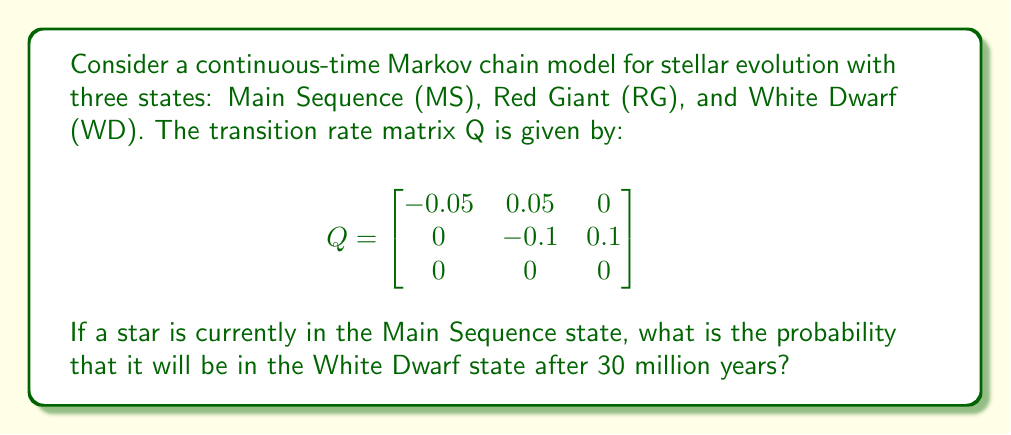What is the answer to this math problem? To solve this problem, we need to calculate the transition probability matrix P(t) for t = 30 million years. We can use the matrix exponential method:

1) The general formula for P(t) is:
   $$ P(t) = e^{Qt} $$

2) We need to compute $e^{30Q}$. This can be done using eigendecomposition:
   $$ e^{30Q} = S e^{30D} S^{-1} $$
   where D is a diagonal matrix of eigenvalues and S is a matrix of eigenvectors.

3) Calculate the eigenvalues of Q:
   $$ \det(Q - \lambda I) = 0 $$
   $$ (-0.05 - \lambda)(-0.1 - \lambda)(-\lambda) = 0 $$
   $$ \lambda_1 = -0.05, \lambda_2 = -0.1, \lambda_3 = 0 $$

4) Find the corresponding eigenvectors and form S:
   $$ S = \begin{bmatrix}
   1 & 1 & 1 \\
   0 & 1 & 2 \\
   0 & 0 & 1
   \end{bmatrix} $$

5) Calculate $S^{-1}$:
   $$ S^{-1} = \begin{bmatrix}
   1 & -1 & 1 \\
   0 & 1 & -2 \\
   0 & 0 & 1
   \end{bmatrix} $$

6) Compute $e^{30D}$:
   $$ e^{30D} = \begin{bmatrix}
   e^{-1.5} & 0 & 0 \\
   0 & e^{-3} & 0 \\
   0 & 0 & 1
   \end{bmatrix} $$

7) Calculate $P(30) = S e^{30D} S^{-1}$:
   $$ P(30) \approx \begin{bmatrix}
   0.2231 & 0.5769 & 0.2000 \\
   0 & 0.0498 & 0.9502 \\
   0 & 0 & 1
   \end{bmatrix} $$

8) The probability of transitioning from MS to WD after 30 million years is given by the element in the first row, third column of P(30), which is approximately 0.2000.
Answer: 0.2000 